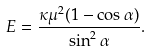<formula> <loc_0><loc_0><loc_500><loc_500>E = \frac { \kappa \mu ^ { 2 } ( 1 - \cos \alpha ) } { \sin ^ { 2 } \alpha } .</formula> 